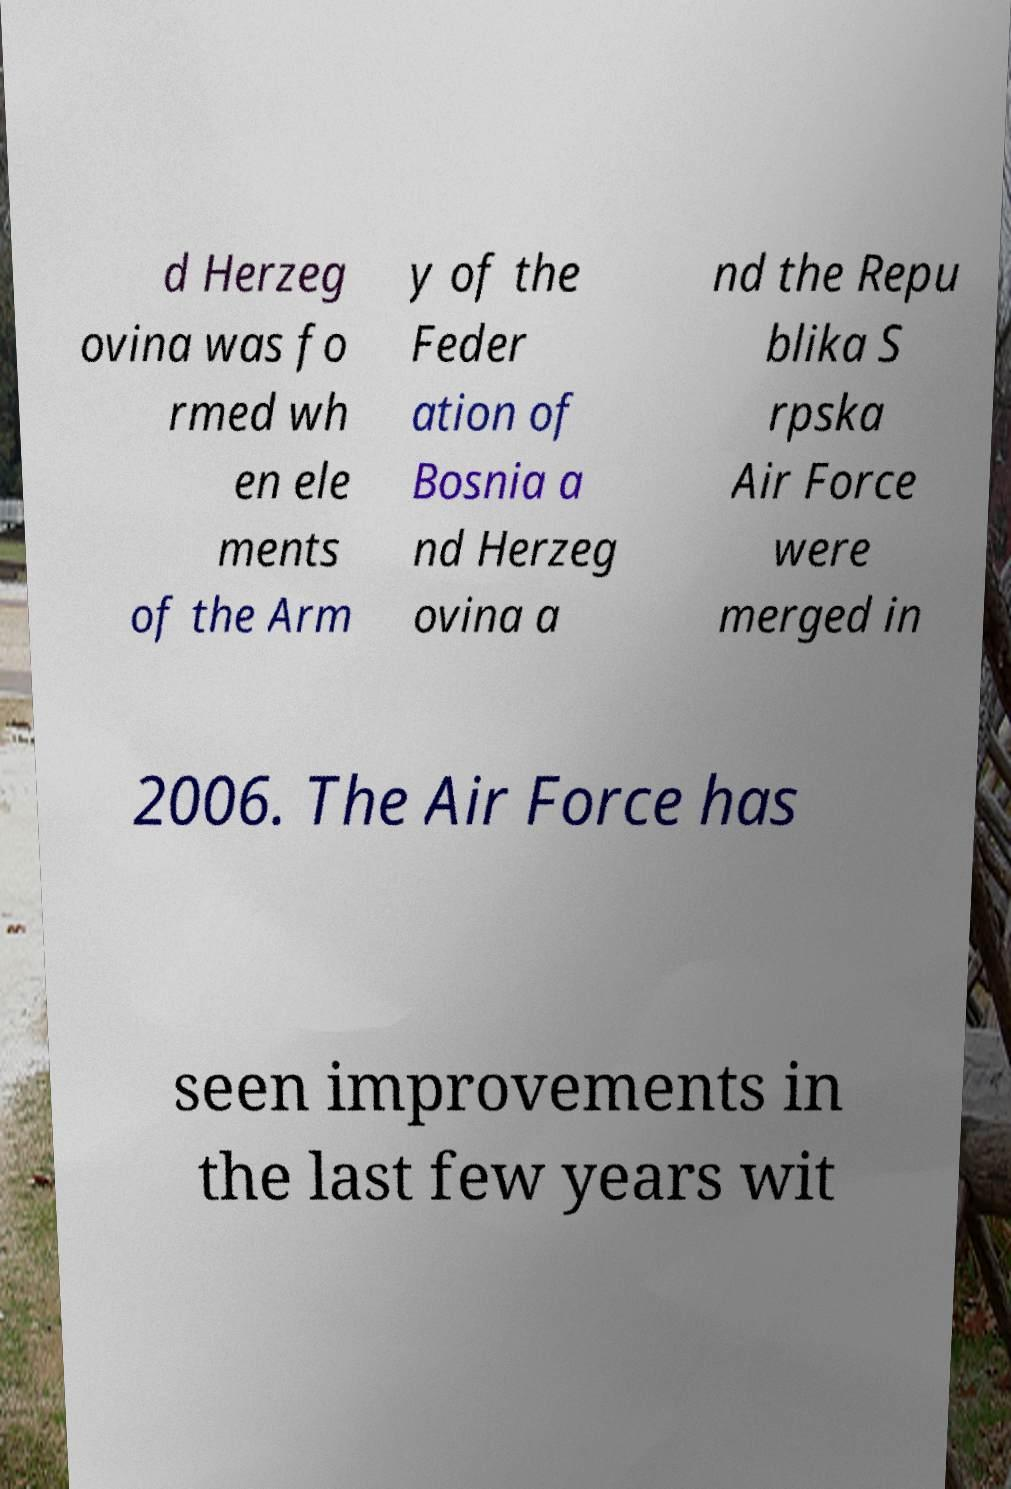Please identify and transcribe the text found in this image. d Herzeg ovina was fo rmed wh en ele ments of the Arm y of the Feder ation of Bosnia a nd Herzeg ovina a nd the Repu blika S rpska Air Force were merged in 2006. The Air Force has seen improvements in the last few years wit 